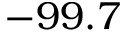Convert formula to latex. <formula><loc_0><loc_0><loc_500><loc_500>- 9 9 . 7</formula> 